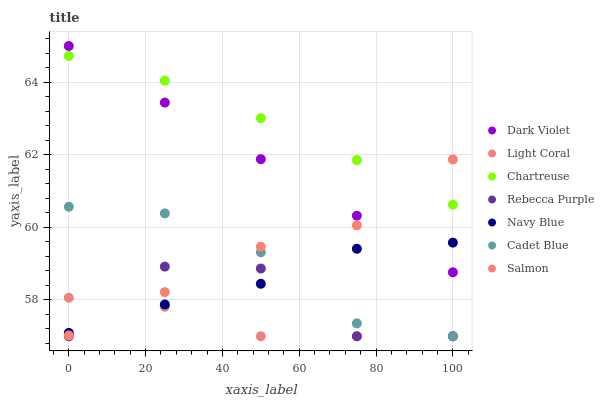Does Light Coral have the minimum area under the curve?
Answer yes or no. Yes. Does Chartreuse have the maximum area under the curve?
Answer yes or no. Yes. Does Navy Blue have the minimum area under the curve?
Answer yes or no. No. Does Navy Blue have the maximum area under the curve?
Answer yes or no. No. Is Dark Violet the smoothest?
Answer yes or no. Yes. Is Rebecca Purple the roughest?
Answer yes or no. Yes. Is Navy Blue the smoothest?
Answer yes or no. No. Is Navy Blue the roughest?
Answer yes or no. No. Does Cadet Blue have the lowest value?
Answer yes or no. Yes. Does Navy Blue have the lowest value?
Answer yes or no. No. Does Dark Violet have the highest value?
Answer yes or no. Yes. Does Navy Blue have the highest value?
Answer yes or no. No. Is Cadet Blue less than Dark Violet?
Answer yes or no. Yes. Is Chartreuse greater than Rebecca Purple?
Answer yes or no. Yes. Does Light Coral intersect Cadet Blue?
Answer yes or no. Yes. Is Light Coral less than Cadet Blue?
Answer yes or no. No. Is Light Coral greater than Cadet Blue?
Answer yes or no. No. Does Cadet Blue intersect Dark Violet?
Answer yes or no. No. 